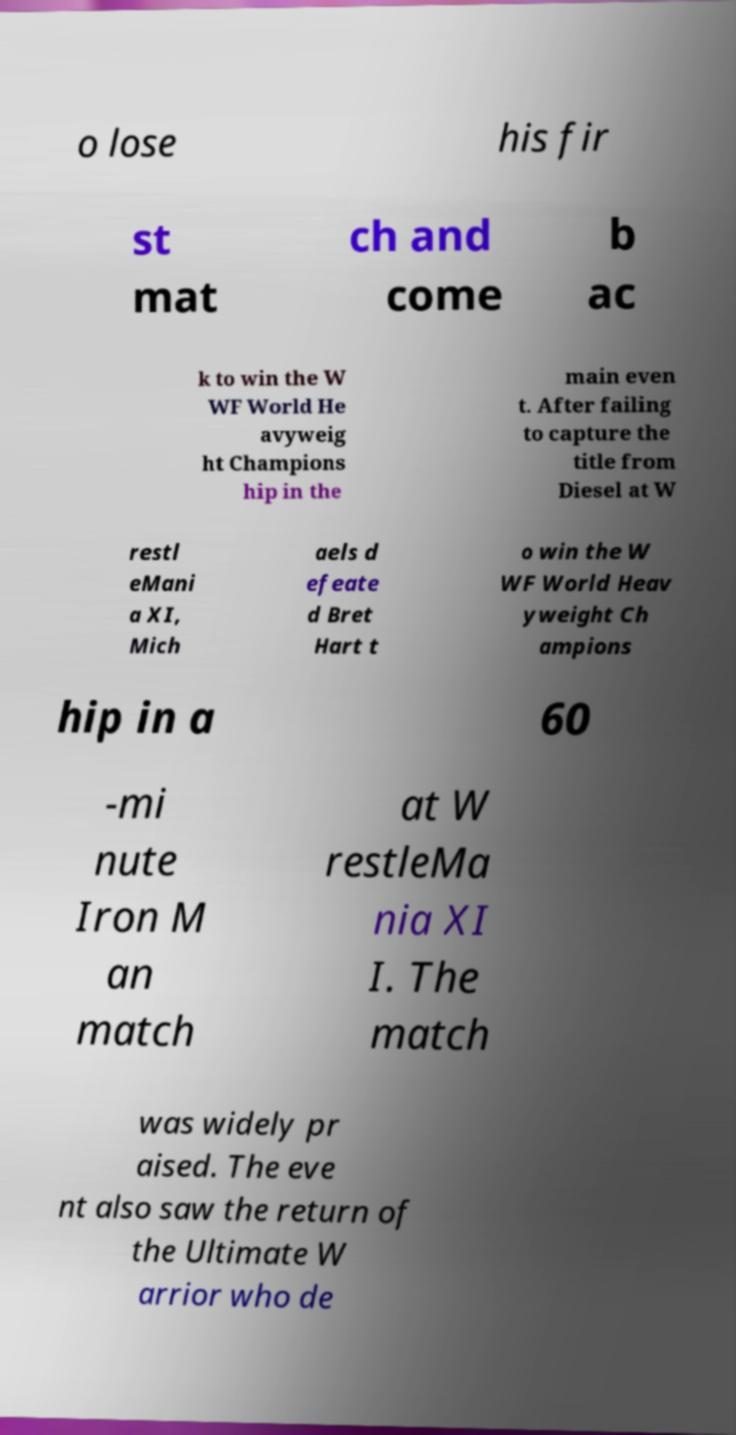I need the written content from this picture converted into text. Can you do that? o lose his fir st mat ch and come b ac k to win the W WF World He avyweig ht Champions hip in the main even t. After failing to capture the title from Diesel at W restl eMani a XI, Mich aels d efeate d Bret Hart t o win the W WF World Heav yweight Ch ampions hip in a 60 -mi nute Iron M an match at W restleMa nia XI I. The match was widely pr aised. The eve nt also saw the return of the Ultimate W arrior who de 